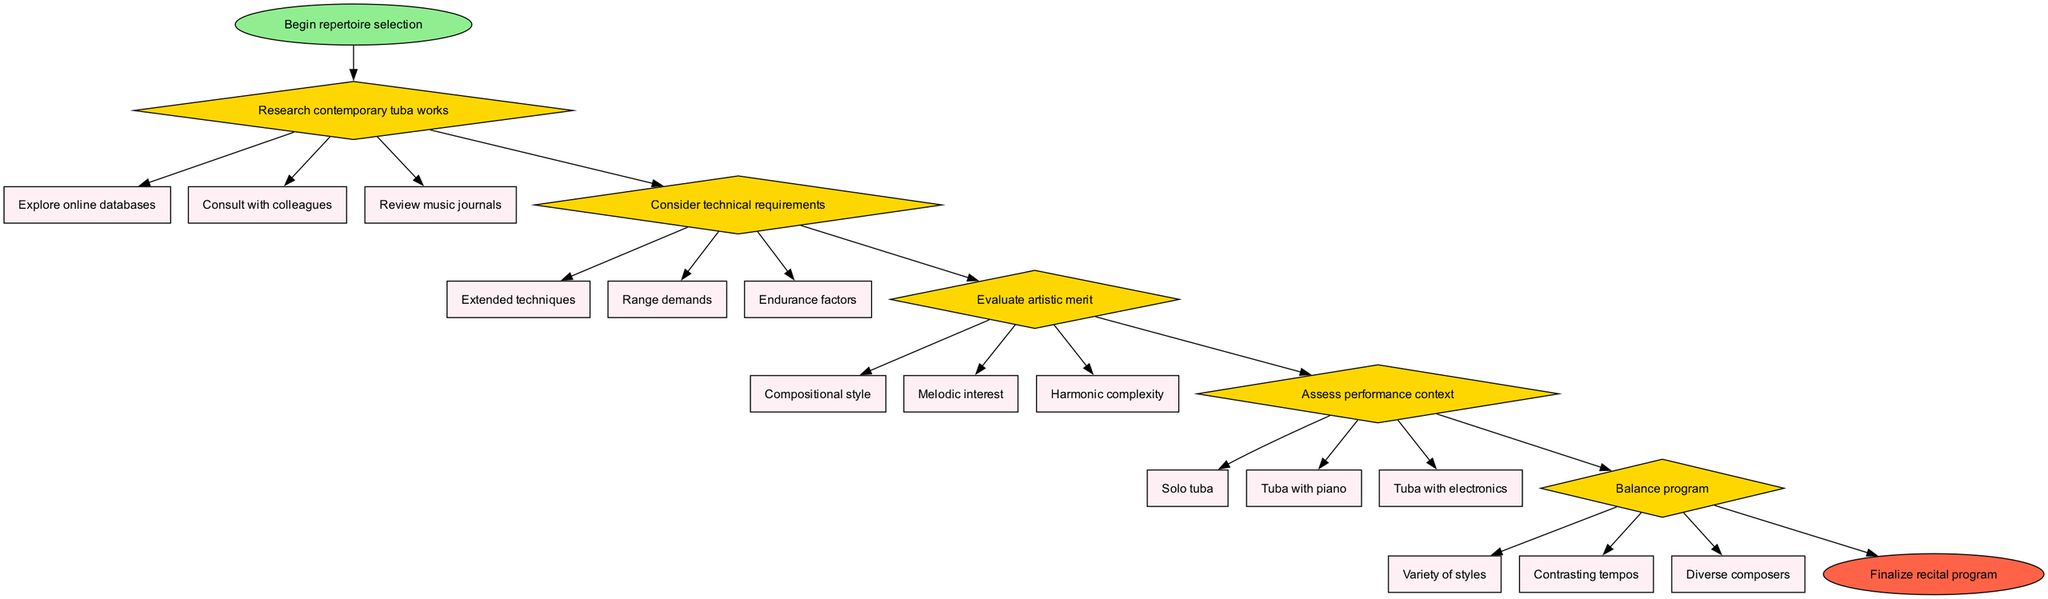What is the first decision node in the diagram? The first decision node in the diagram is "Research contemporary tuba works" which follows the starting point of the decision-making process.
Answer: Research contemporary tuba works How many options are provided for assessing performance context? The "Assess performance context" decision node provides three options, which are "Solo tuba," "Tuba with piano," and "Tuba with electronics."
Answer: 3 What comes after evaluating artistic merit? The flow chart indicates that after evaluating artistic merit, the next decision node is "Assess performance context." This shows the decision-making order.
Answer: Assess performance context Which color represents the end node? The end node is colored in a reddish tone, specifically represented by the color code "#FF6347." This differentiates it from other nodes in the diagram.
Answer: #FF6347 How many decision nodes are present in the chart? There are five decision nodes in the diagram, which encompass the various considerations laid out in the repertoire selection process.
Answer: 5 What is the last option listed under balancing the program? The last option listed under the "Balance program" decision node is "Diverse composers," which refers to including a variety of composer backgrounds in the recital program.
Answer: Diverse composers Which decision node follows "Consider technical requirements"? Following "Consider technical requirements," the next decision is "Evaluate artistic merit," as illustrated by the flow from one decision to the next in the chart.
Answer: Evaluate artistic merit What type of node is used to represent the beginning of the selection process? The starting point of the diagram is represented as an oval-shaped node, which visually indicates the beginning of the decision-making process.
Answer: Oval 